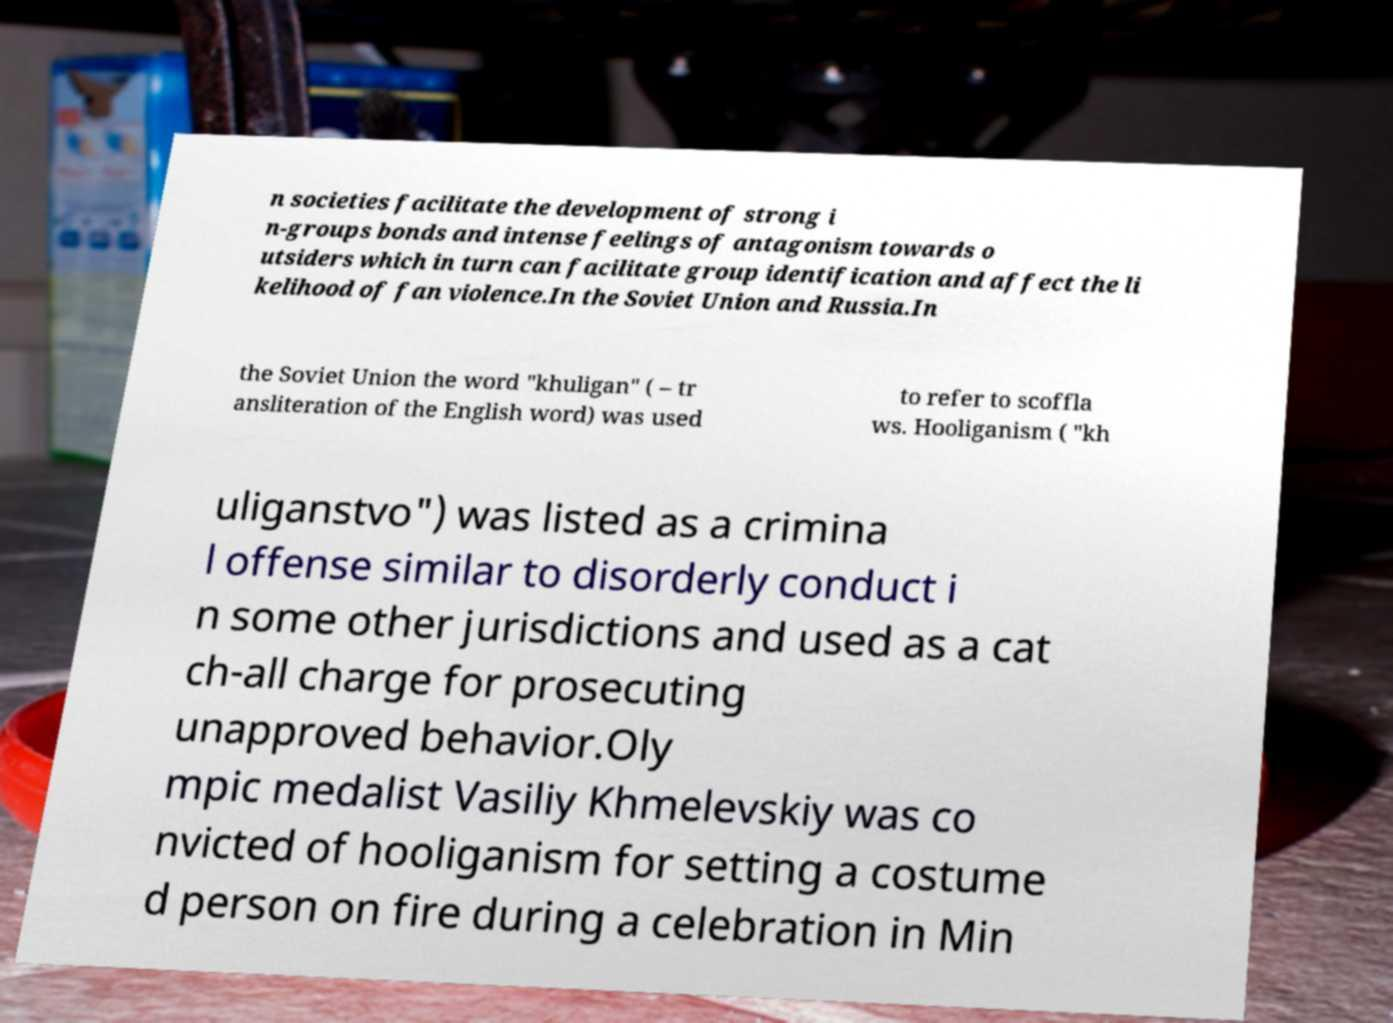Could you extract and type out the text from this image? n societies facilitate the development of strong i n-groups bonds and intense feelings of antagonism towards o utsiders which in turn can facilitate group identification and affect the li kelihood of fan violence.In the Soviet Union and Russia.In the Soviet Union the word "khuligan" ( – tr ansliteration of the English word) was used to refer to scoffla ws. Hooliganism ( "kh uliganstvo") was listed as a crimina l offense similar to disorderly conduct i n some other jurisdictions and used as a cat ch-all charge for prosecuting unapproved behavior.Oly mpic medalist Vasiliy Khmelevskiy was co nvicted of hooliganism for setting a costume d person on fire during a celebration in Min 